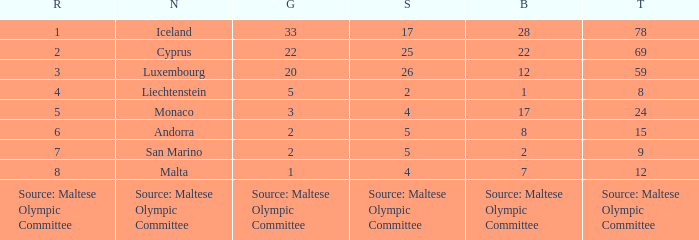What is the number of gold medals when the number of bronze medals is 8? 2.0. 